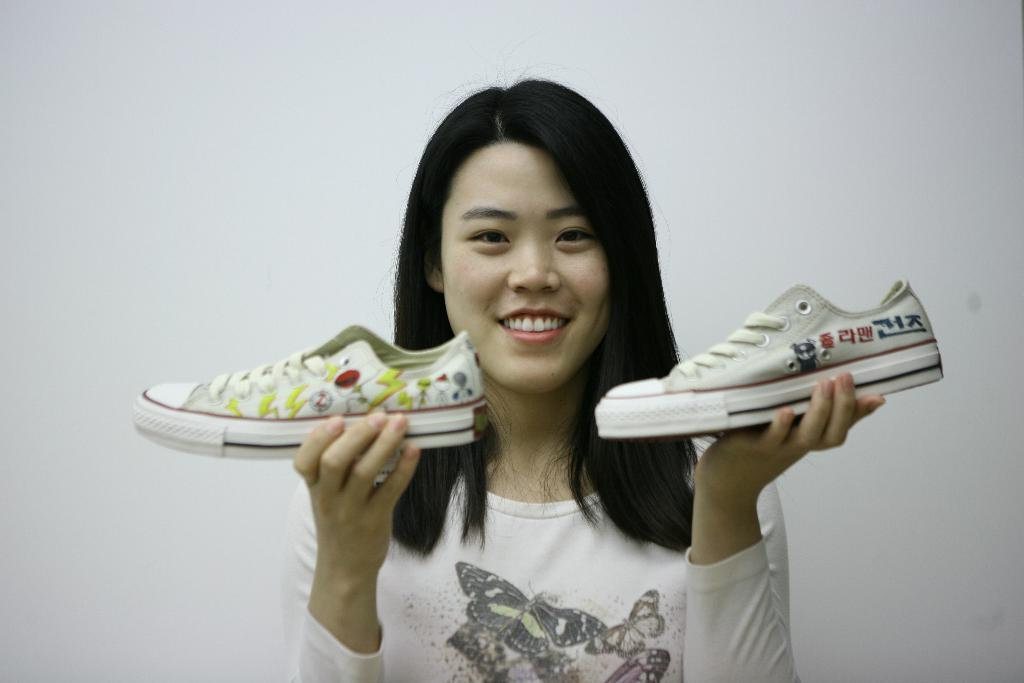Who is the main subject in the image? There is a girl in the image. What is the girl doing in the image? The girl is smiling in the image. What is the girl holding in her hand? The girl is holding a pair of shoes in her hand. What can be seen behind the girl in the image? There is a wall behind the girl. Where is the pocket located on the girl in the image? There is no pocket visible on the girl in the image. What type of lock is used on the wall behind the girl? There is no lock visible on the wall behind the girl in the image. 